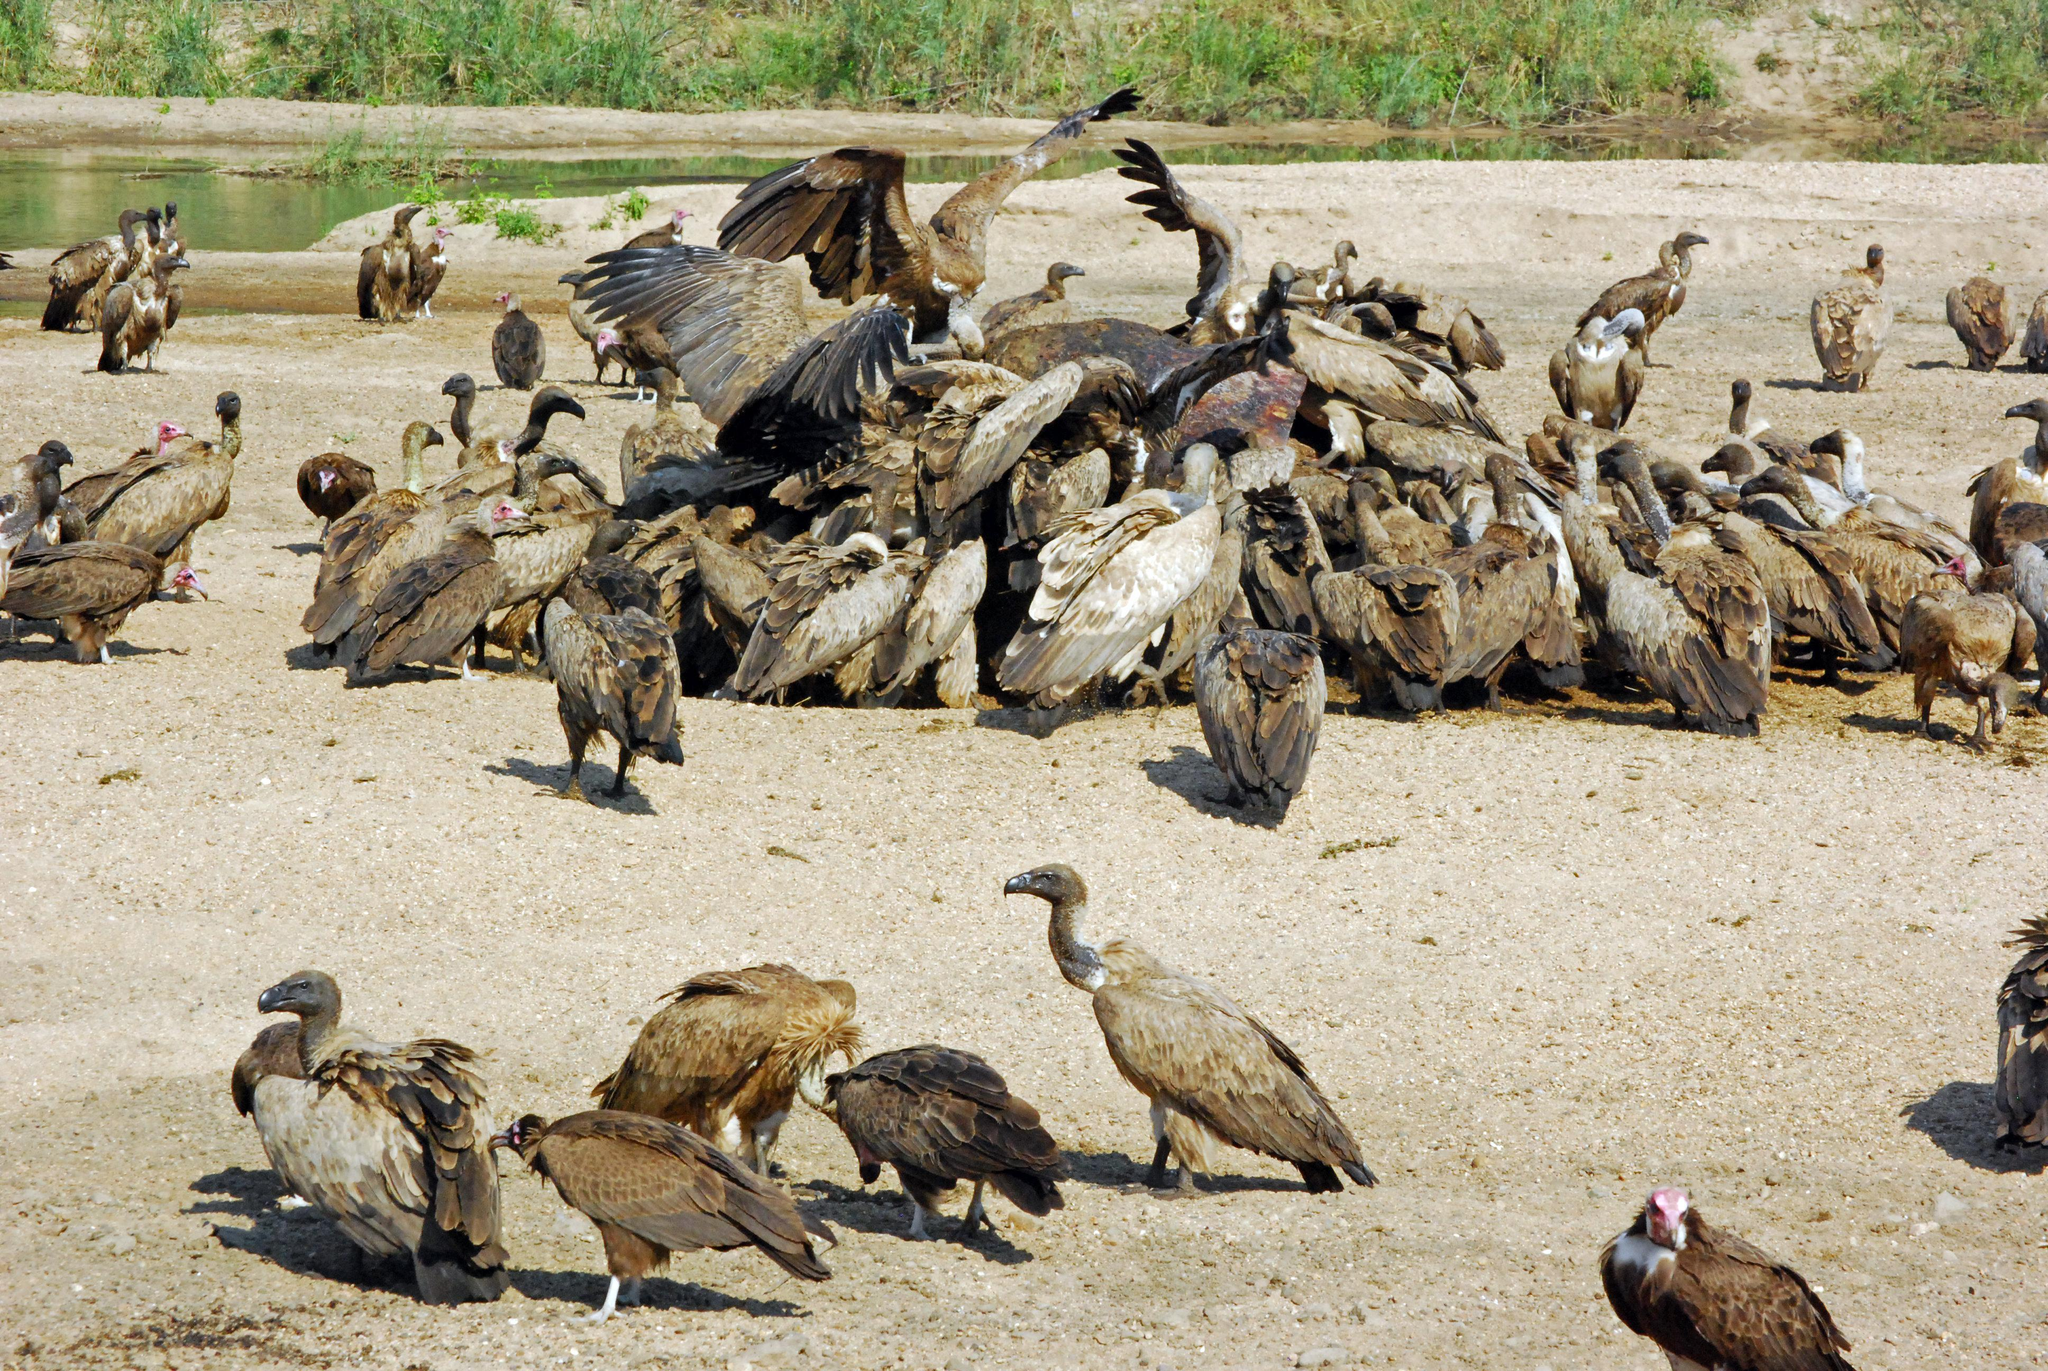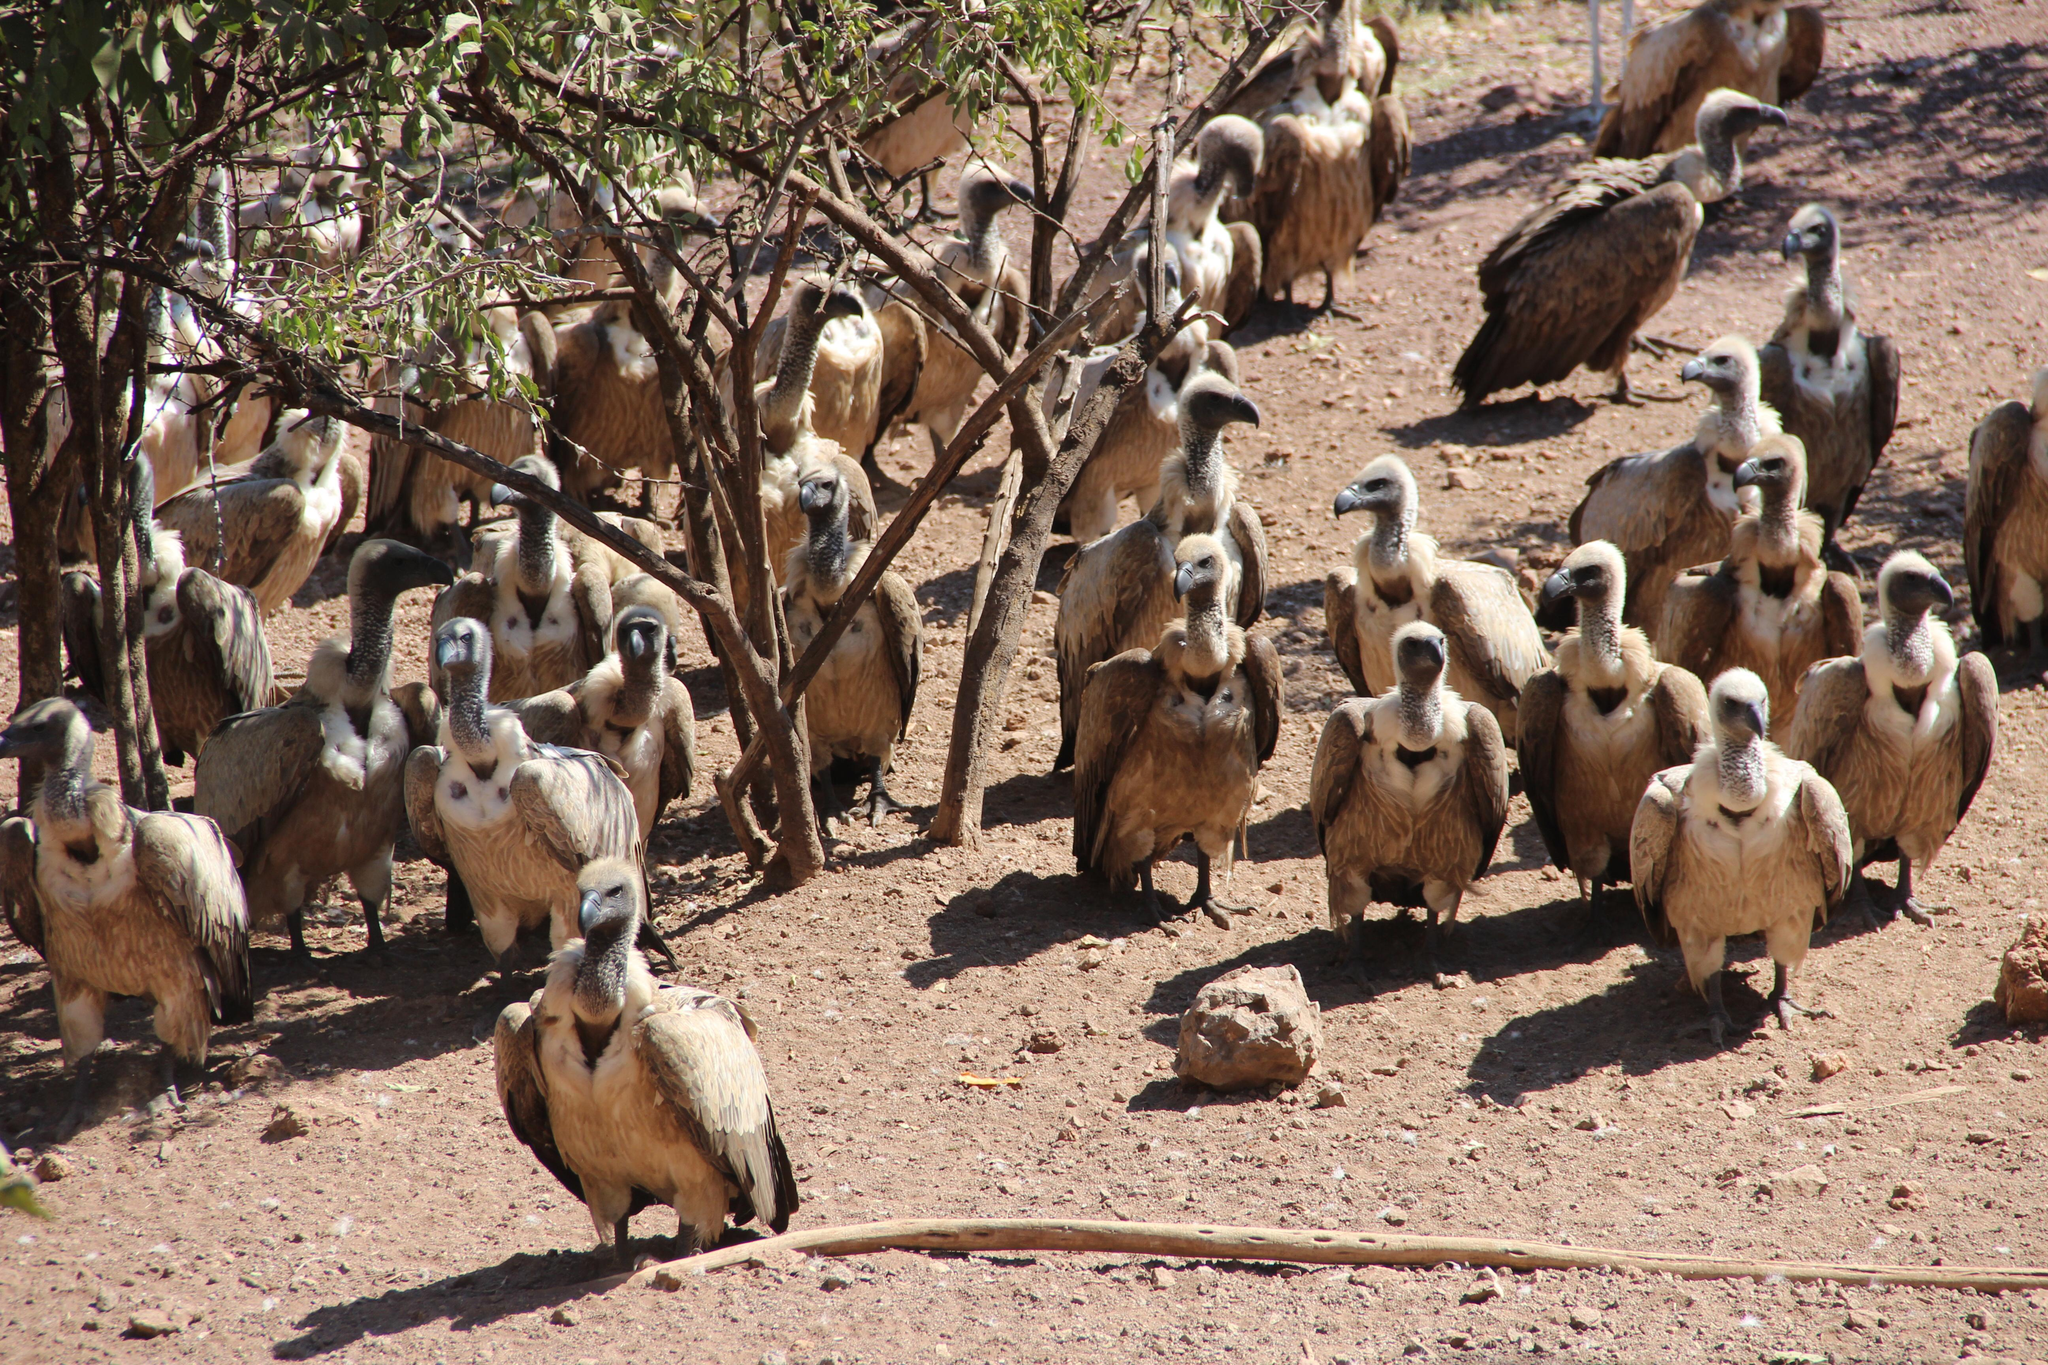The first image is the image on the left, the second image is the image on the right. Given the left and right images, does the statement "The carrion being eaten by the birds in the image on the left can be clearly seen." hold true? Answer yes or no. No. 